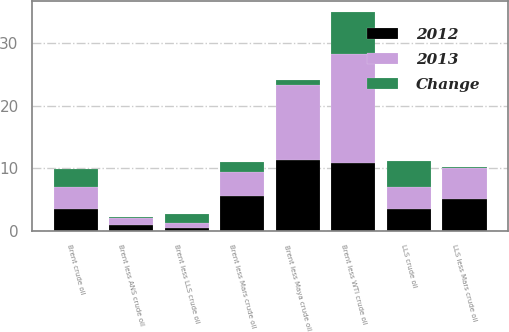<chart> <loc_0><loc_0><loc_500><loc_500><stacked_bar_chart><ecel><fcel>Brent crude oil<fcel>Brent less WTI crude oil<fcel>Brent less ANS crude oil<fcel>Brent less LLS crude oil<fcel>Brent less Mars crude oil<fcel>Brent less Maya crude oil<fcel>LLS crude oil<fcel>LLS less Mars crude oil<nl><fcel>2012<fcel>3.465<fcel>10.8<fcel>1<fcel>0.41<fcel>5.52<fcel>11.31<fcel>3.465<fcel>5.11<nl><fcel>2013<fcel>3.465<fcel>17.55<fcel>1.08<fcel>0.91<fcel>3.97<fcel>12.06<fcel>3.465<fcel>4.88<nl><fcel>Change<fcel>2.96<fcel>6.75<fcel>0.08<fcel>1.32<fcel>1.55<fcel>0.75<fcel>4.28<fcel>0.23<nl></chart> 